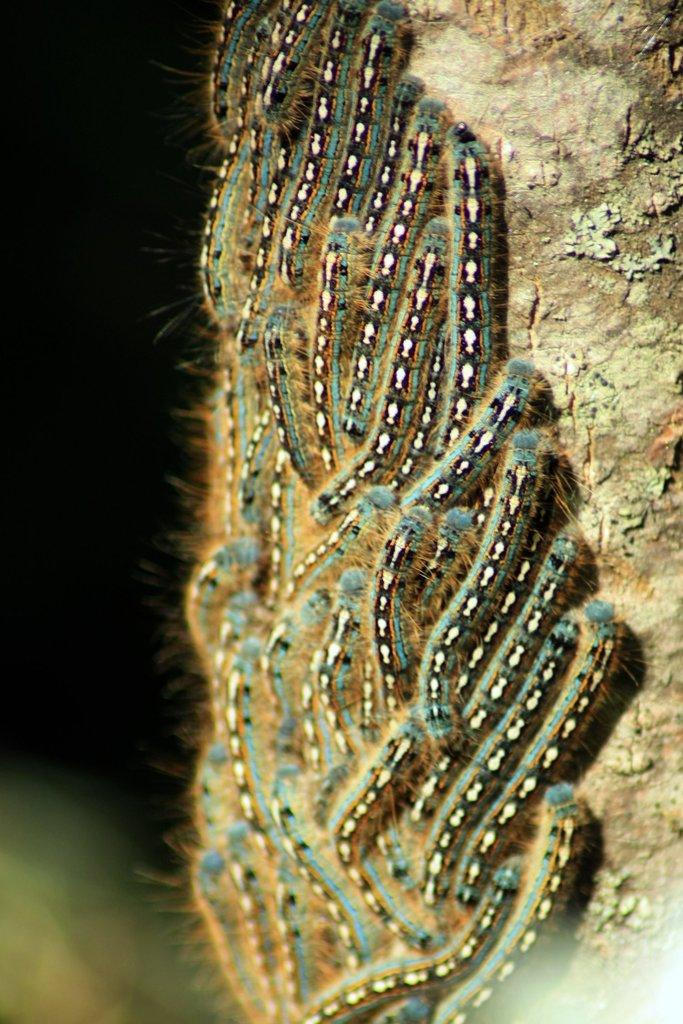What type of creatures are present in the image? There is a group of insects in the image. What surface are the insects located on? The insects are on a wooden surface. What can be observed about the background of the image? The background of the image is dark. What type of gun is the father holding in the image? There is no father or gun present in the image; it features a group of insects on a wooden surface with a dark background. 